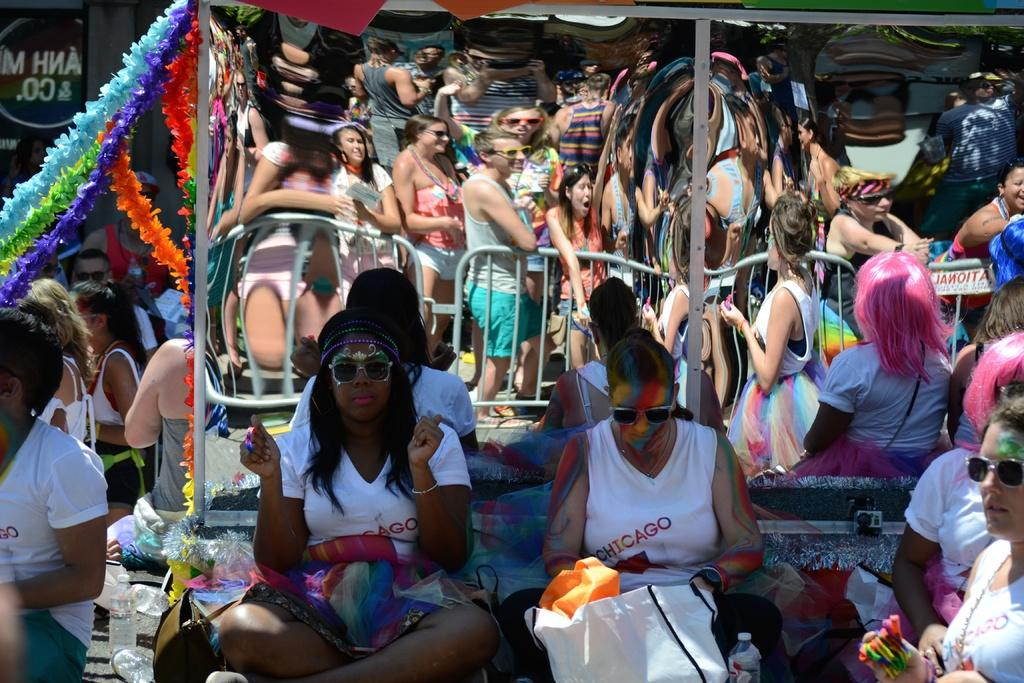What can be seen in the image regarding the people present? There are women sitting in the image. What object in the image can show reflections? There is a mirror in the image that can show reflections. What does the mirror reflect in the image? The mirror reflects people and a fence in the image. What type of noise can be heard coming from the boy in the image? There is no boy present in the image, so it's not possible to determine what noise might be heard. 